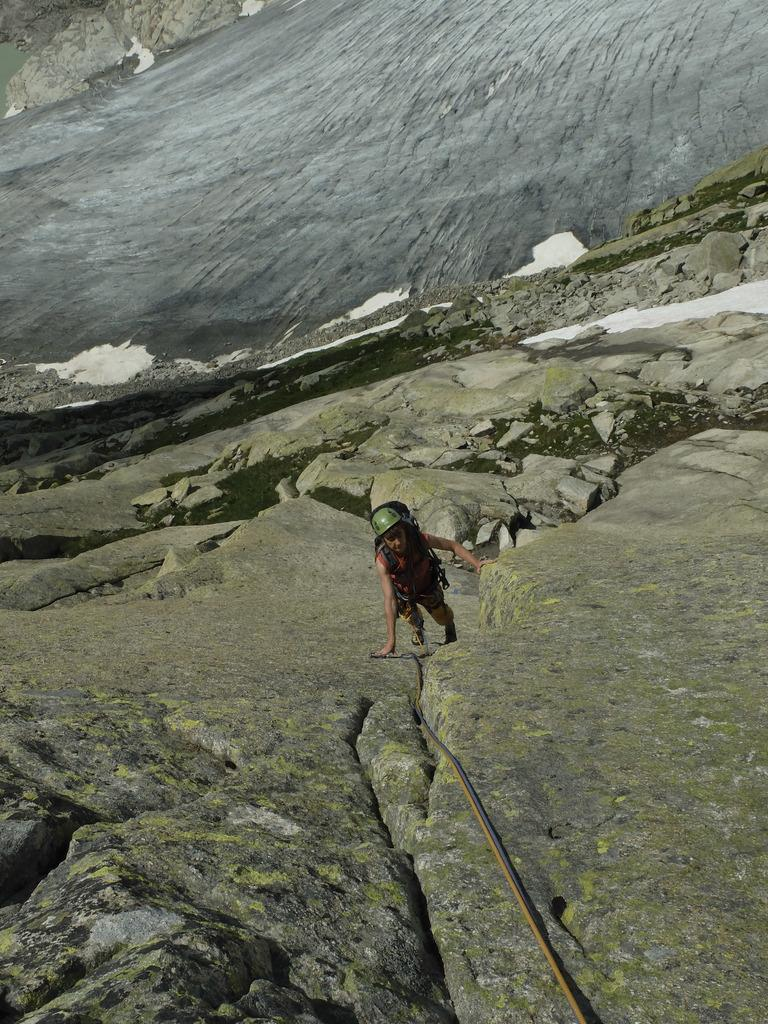What is the main subject in the center of the image? There is a man standing in the center of the image. What type of geographical feature is at the bottom of the image? There are mountains at the bottom of the image. What can be seen in the background of the image? Mountains and a river are visible in the background of the image. What type of insurance does the man have in the image? There is no information about insurance in the image, as it focuses on the man and the surrounding geographical features. 